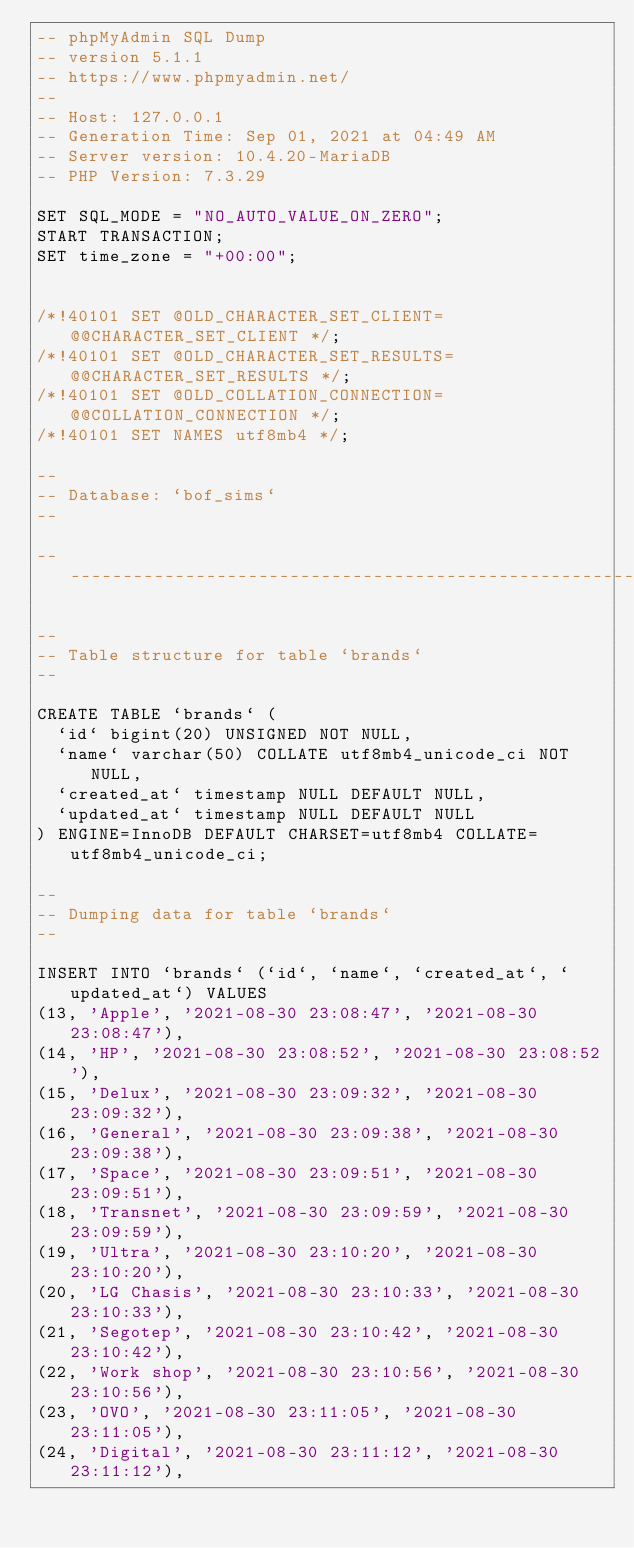<code> <loc_0><loc_0><loc_500><loc_500><_SQL_>-- phpMyAdmin SQL Dump
-- version 5.1.1
-- https://www.phpmyadmin.net/
--
-- Host: 127.0.0.1
-- Generation Time: Sep 01, 2021 at 04:49 AM
-- Server version: 10.4.20-MariaDB
-- PHP Version: 7.3.29

SET SQL_MODE = "NO_AUTO_VALUE_ON_ZERO";
START TRANSACTION;
SET time_zone = "+00:00";


/*!40101 SET @OLD_CHARACTER_SET_CLIENT=@@CHARACTER_SET_CLIENT */;
/*!40101 SET @OLD_CHARACTER_SET_RESULTS=@@CHARACTER_SET_RESULTS */;
/*!40101 SET @OLD_COLLATION_CONNECTION=@@COLLATION_CONNECTION */;
/*!40101 SET NAMES utf8mb4 */;

--
-- Database: `bof_sims`
--

-- --------------------------------------------------------

--
-- Table structure for table `brands`
--

CREATE TABLE `brands` (
  `id` bigint(20) UNSIGNED NOT NULL,
  `name` varchar(50) COLLATE utf8mb4_unicode_ci NOT NULL,
  `created_at` timestamp NULL DEFAULT NULL,
  `updated_at` timestamp NULL DEFAULT NULL
) ENGINE=InnoDB DEFAULT CHARSET=utf8mb4 COLLATE=utf8mb4_unicode_ci;

--
-- Dumping data for table `brands`
--

INSERT INTO `brands` (`id`, `name`, `created_at`, `updated_at`) VALUES
(13, 'Apple', '2021-08-30 23:08:47', '2021-08-30 23:08:47'),
(14, 'HP', '2021-08-30 23:08:52', '2021-08-30 23:08:52'),
(15, 'Delux', '2021-08-30 23:09:32', '2021-08-30 23:09:32'),
(16, 'General', '2021-08-30 23:09:38', '2021-08-30 23:09:38'),
(17, 'Space', '2021-08-30 23:09:51', '2021-08-30 23:09:51'),
(18, 'Transnet', '2021-08-30 23:09:59', '2021-08-30 23:09:59'),
(19, 'Ultra', '2021-08-30 23:10:20', '2021-08-30 23:10:20'),
(20, 'LG Chasis', '2021-08-30 23:10:33', '2021-08-30 23:10:33'),
(21, 'Segotep', '2021-08-30 23:10:42', '2021-08-30 23:10:42'),
(22, 'Work shop', '2021-08-30 23:10:56', '2021-08-30 23:10:56'),
(23, 'OVO', '2021-08-30 23:11:05', '2021-08-30 23:11:05'),
(24, 'Digital', '2021-08-30 23:11:12', '2021-08-30 23:11:12'),</code> 